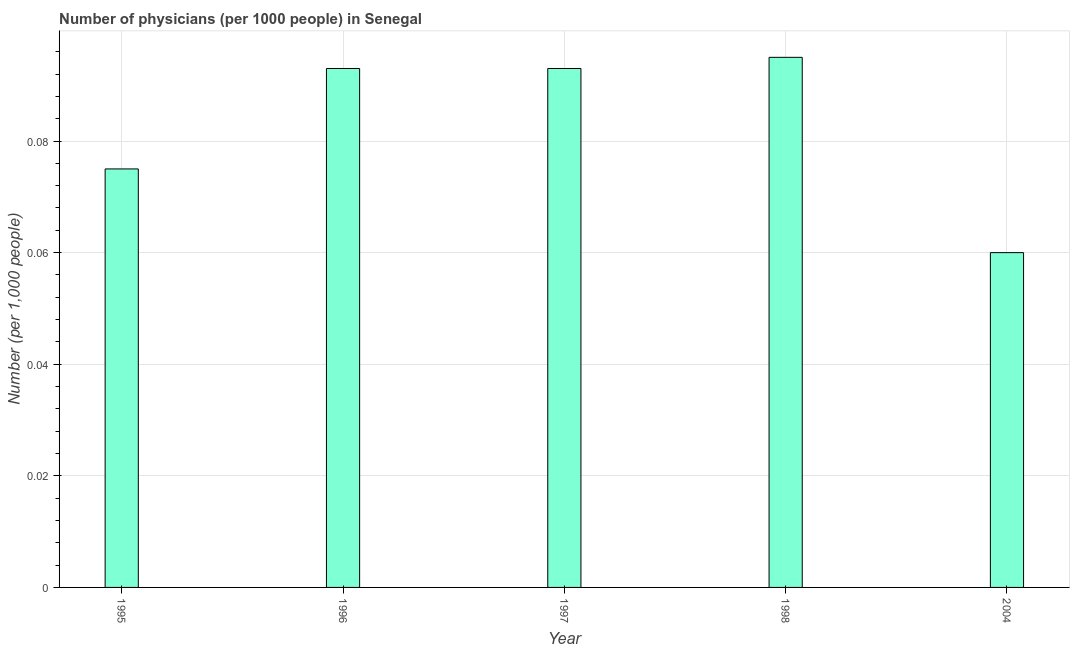Does the graph contain any zero values?
Your answer should be compact. No. What is the title of the graph?
Provide a short and direct response. Number of physicians (per 1000 people) in Senegal. What is the label or title of the X-axis?
Make the answer very short. Year. What is the label or title of the Y-axis?
Keep it short and to the point. Number (per 1,0 people). What is the number of physicians in 1997?
Make the answer very short. 0.09. Across all years, what is the maximum number of physicians?
Your answer should be very brief. 0.1. Across all years, what is the minimum number of physicians?
Your response must be concise. 0.06. What is the sum of the number of physicians?
Your answer should be very brief. 0.42. What is the difference between the number of physicians in 1997 and 2004?
Keep it short and to the point. 0.03. What is the average number of physicians per year?
Offer a very short reply. 0.08. What is the median number of physicians?
Your answer should be compact. 0.09. In how many years, is the number of physicians greater than 0.028 ?
Offer a very short reply. 5. Do a majority of the years between 1995 and 2004 (inclusive) have number of physicians greater than 0.064 ?
Your response must be concise. Yes. What is the ratio of the number of physicians in 1995 to that in 1997?
Your response must be concise. 0.81. Is the difference between the number of physicians in 1996 and 1997 greater than the difference between any two years?
Ensure brevity in your answer.  No. What is the difference between the highest and the second highest number of physicians?
Keep it short and to the point. 0. Is the sum of the number of physicians in 1996 and 1998 greater than the maximum number of physicians across all years?
Make the answer very short. Yes. In how many years, is the number of physicians greater than the average number of physicians taken over all years?
Keep it short and to the point. 3. How many bars are there?
Keep it short and to the point. 5. How many years are there in the graph?
Offer a very short reply. 5. What is the difference between two consecutive major ticks on the Y-axis?
Make the answer very short. 0.02. What is the Number (per 1,000 people) of 1995?
Provide a succinct answer. 0.07. What is the Number (per 1,000 people) of 1996?
Provide a succinct answer. 0.09. What is the Number (per 1,000 people) of 1997?
Make the answer very short. 0.09. What is the Number (per 1,000 people) of 1998?
Offer a terse response. 0.1. What is the Number (per 1,000 people) of 2004?
Provide a succinct answer. 0.06. What is the difference between the Number (per 1,000 people) in 1995 and 1996?
Your response must be concise. -0.02. What is the difference between the Number (per 1,000 people) in 1995 and 1997?
Make the answer very short. -0.02. What is the difference between the Number (per 1,000 people) in 1995 and 1998?
Offer a very short reply. -0.02. What is the difference between the Number (per 1,000 people) in 1995 and 2004?
Keep it short and to the point. 0.01. What is the difference between the Number (per 1,000 people) in 1996 and 1997?
Provide a short and direct response. 0. What is the difference between the Number (per 1,000 people) in 1996 and 1998?
Offer a terse response. -0. What is the difference between the Number (per 1,000 people) in 1996 and 2004?
Keep it short and to the point. 0.03. What is the difference between the Number (per 1,000 people) in 1997 and 1998?
Offer a very short reply. -0. What is the difference between the Number (per 1,000 people) in 1997 and 2004?
Your answer should be compact. 0.03. What is the difference between the Number (per 1,000 people) in 1998 and 2004?
Keep it short and to the point. 0.04. What is the ratio of the Number (per 1,000 people) in 1995 to that in 1996?
Offer a very short reply. 0.81. What is the ratio of the Number (per 1,000 people) in 1995 to that in 1997?
Provide a short and direct response. 0.81. What is the ratio of the Number (per 1,000 people) in 1995 to that in 1998?
Provide a succinct answer. 0.79. What is the ratio of the Number (per 1,000 people) in 1995 to that in 2004?
Your answer should be very brief. 1.25. What is the ratio of the Number (per 1,000 people) in 1996 to that in 1998?
Provide a short and direct response. 0.98. What is the ratio of the Number (per 1,000 people) in 1996 to that in 2004?
Make the answer very short. 1.55. What is the ratio of the Number (per 1,000 people) in 1997 to that in 1998?
Your answer should be compact. 0.98. What is the ratio of the Number (per 1,000 people) in 1997 to that in 2004?
Make the answer very short. 1.55. What is the ratio of the Number (per 1,000 people) in 1998 to that in 2004?
Make the answer very short. 1.58. 